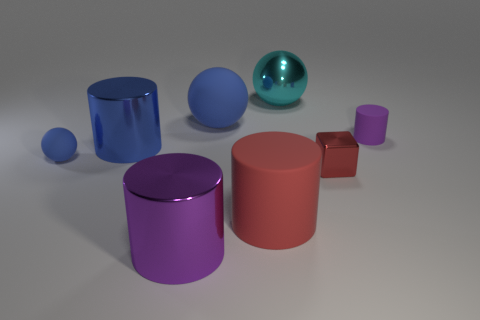Subtract all cyan balls. How many purple cylinders are left? 2 Subtract all red cylinders. How many cylinders are left? 3 Subtract 2 cylinders. How many cylinders are left? 2 Add 1 red shiny cubes. How many objects exist? 9 Subtract all blue metal cylinders. How many cylinders are left? 3 Subtract all green balls. Subtract all brown cylinders. How many balls are left? 3 Subtract 0 gray cylinders. How many objects are left? 8 Subtract all blocks. How many objects are left? 7 Subtract all cubes. Subtract all big metallic objects. How many objects are left? 4 Add 2 red blocks. How many red blocks are left? 3 